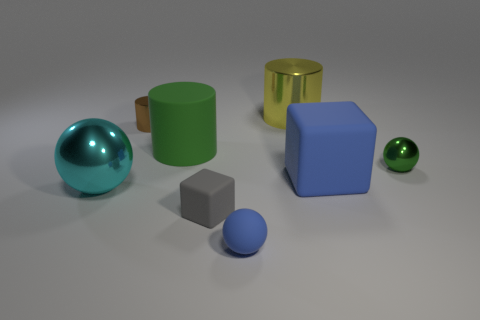The big object that is both behind the big blue rubber cube and right of the blue matte ball is what color?
Your response must be concise. Yellow. Is the number of shiny cylinders less than the number of large blue matte cubes?
Your answer should be compact. No. Do the matte ball and the large matte thing in front of the green metallic ball have the same color?
Offer a terse response. Yes. Is the number of gray matte objects that are in front of the green metallic ball the same as the number of gray matte blocks that are in front of the yellow object?
Make the answer very short. Yes. What number of other large objects have the same shape as the gray object?
Offer a terse response. 1. Is there a green object?
Your answer should be compact. Yes. Is the material of the big yellow cylinder the same as the sphere that is in front of the big cyan metallic sphere?
Ensure brevity in your answer.  No. There is a brown cylinder that is the same size as the green metallic object; what is it made of?
Your answer should be compact. Metal. Are there any small blue things made of the same material as the tiny gray block?
Offer a very short reply. Yes. Are there any small metallic cylinders to the right of the shiny object on the right side of the large blue cube right of the green cylinder?
Offer a very short reply. No. 